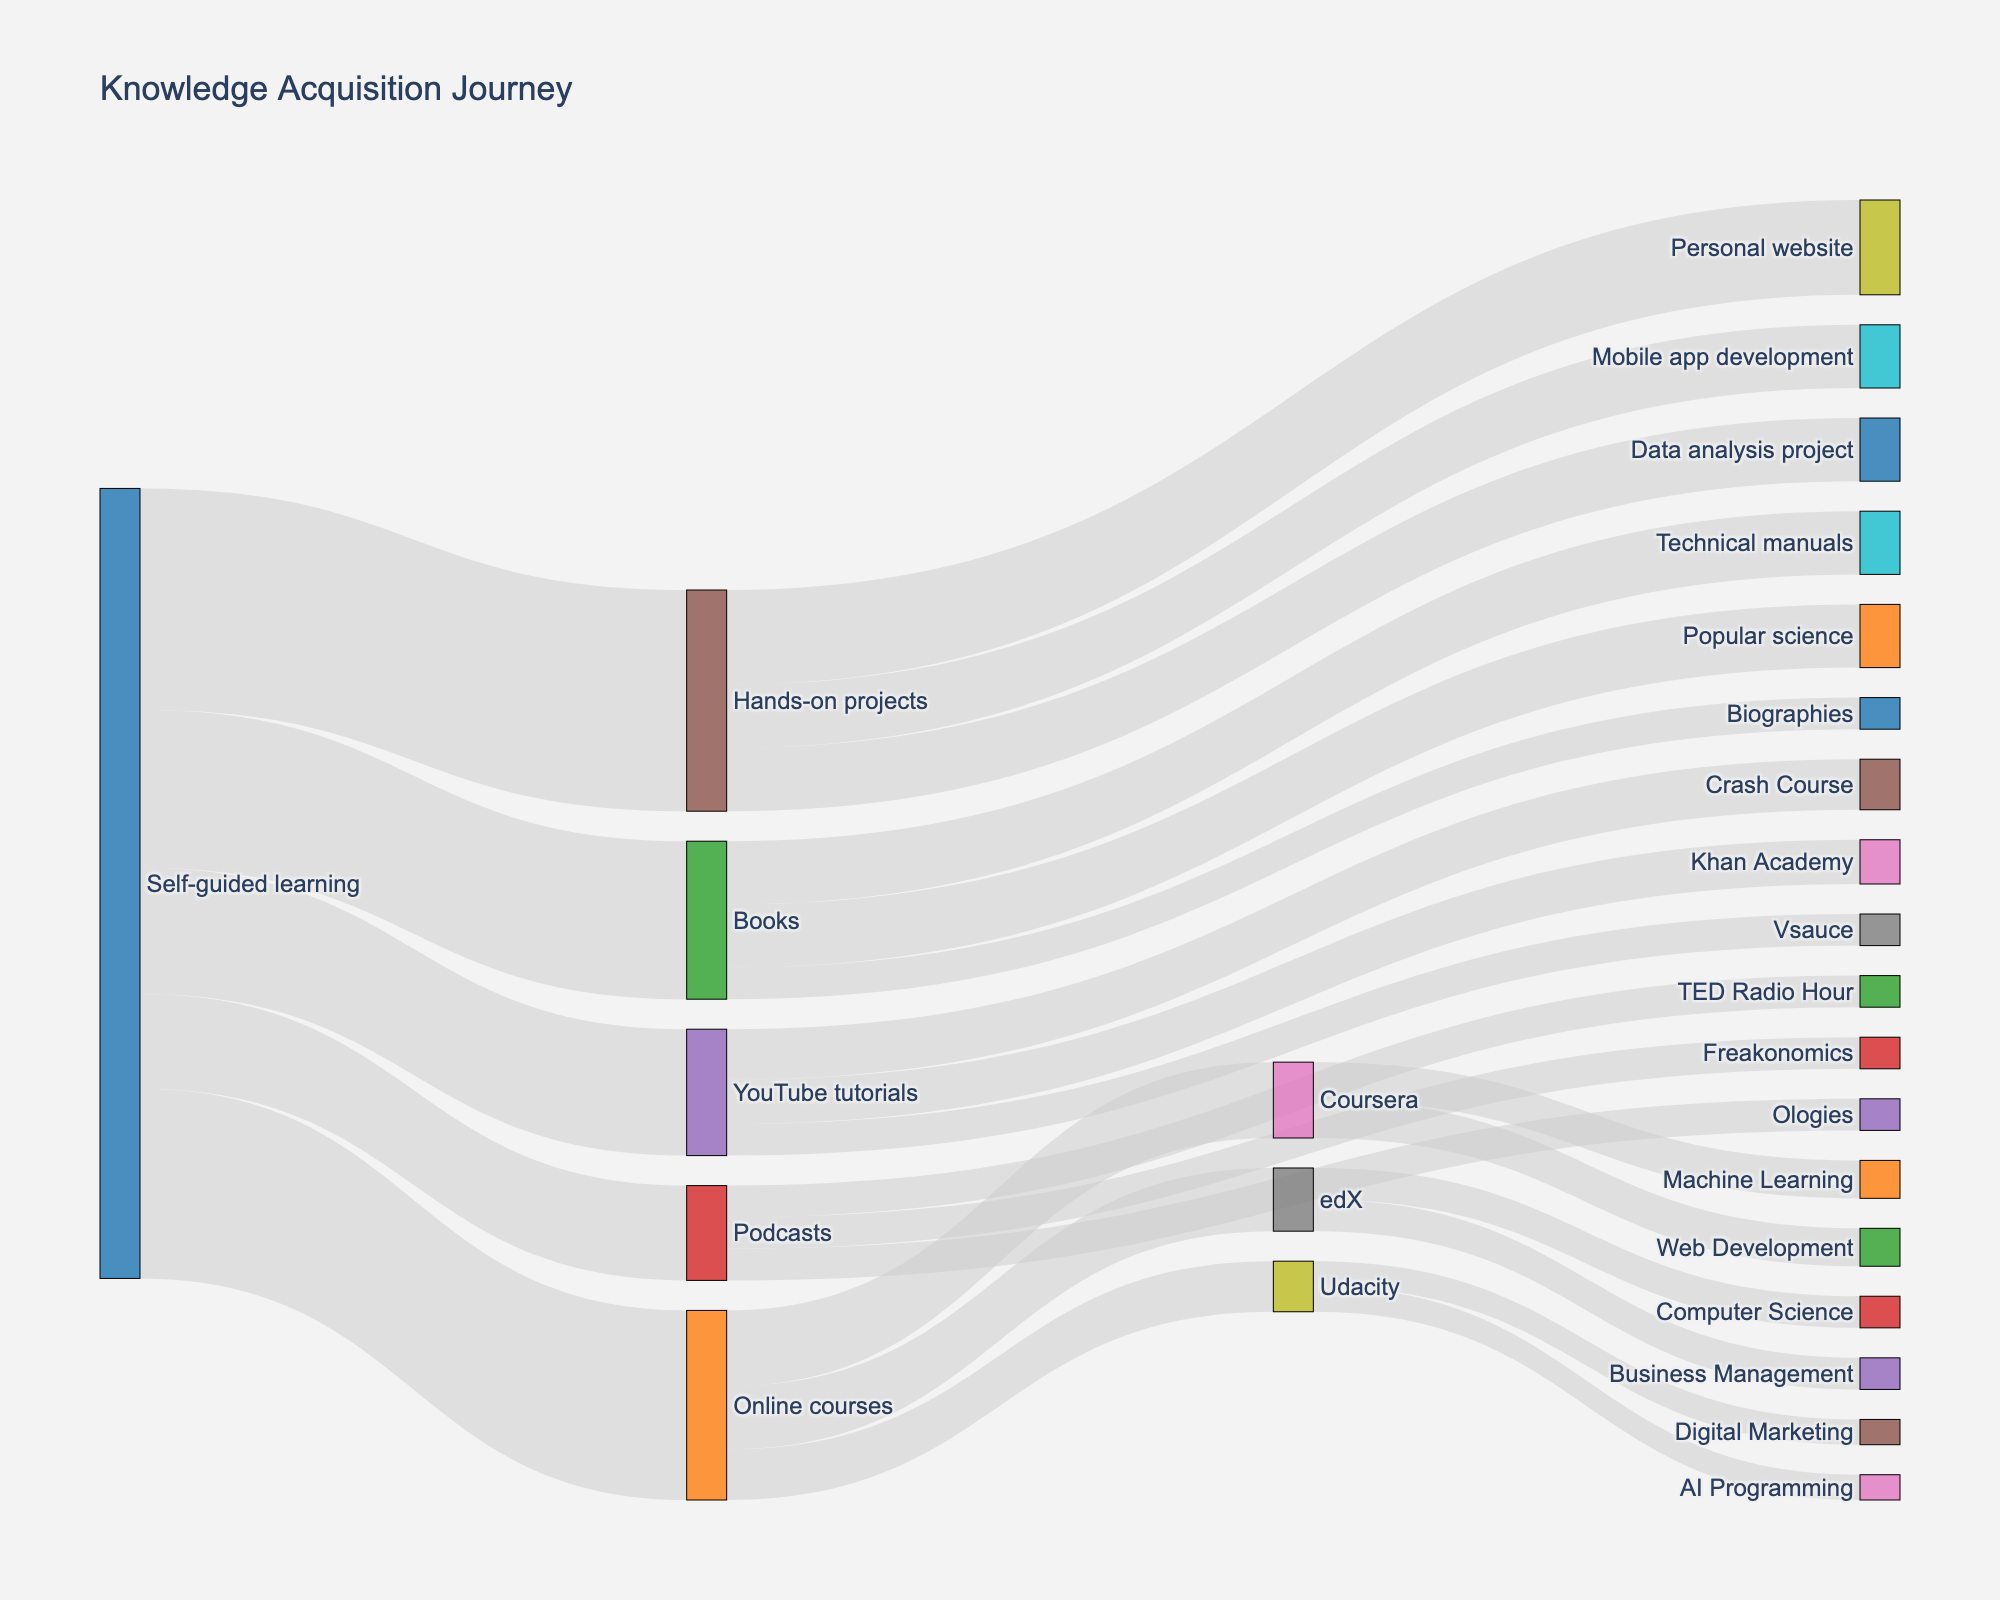What's the title of the figure? The title is typically located at the top of the figure. In this case, it is explicitly set to "Knowledge Acquisition Journey" in the figure attributes.
Answer: Knowledge Acquisition Journey How many unique learning resources are displayed after self-guided learning? By counting the target nodes that are directly connected to 'Self-guided learning,' we see Online courses, Books, Podcasts, YouTube tutorials, and Hands-on projects (5 targets).
Answer: 5 Which specific resource under Online courses has the most connections? By looking at the connections extending from Online courses, Coursera has the most connections (6) compared to edX (5) and Udacity (4).
Answer: Coursera What's the sum of values for resources connected to Books? The values connected to Books are Technical manuals (10), Biographies (5), and Popular science (10). Summing these gives 10 + 5 + 10 = 25.
Answer: 25 Which podcast has the highest associated value? The connections from Podcasts show TED Radio Hour (5), Freakonomics (5), and Ologies (5). All have equal values of 5.
Answer: All have equal values What is the total value of all connections stemming from Hands-on projects? Summing the values for Personal website (15), Mobile app development (10), and Data analysis project (10) gives 15 + 10 + 10 = 35.
Answer: 35 Compare the values of YouTube tutorials and Podcasts, which has a higher total value? Summing the values for YouTube tutorials (Crash Course 8, Khan Academy 7, Vsauce 5 = 20) and Podcasts (TED Radio Hour 5, Freakonomics 5, Ologies 5 = 15), we see YouTube tutorials have a higher total value.
Answer: YouTube tutorials What are the values associated with Coursera courses? Looking at the target connections from Coursera, the values are Machine Learning (6) and Web Development (6).
Answer: 6 and 6 How is the value of Online courses distributed among Coursera, edX, and Udacity? Summing the values, Coursera (12), edX (10), and Udacity (8). This results in Coursera having the most, followed by edX, and Udacity last.
Answer: Coursera > edX > Udacity What can you infer about my preferred method for self-guided learning? The Hands-on projects have the highest value (35), indicating a preference for practical, hands-on learning.
Answer: Hands-on projects 